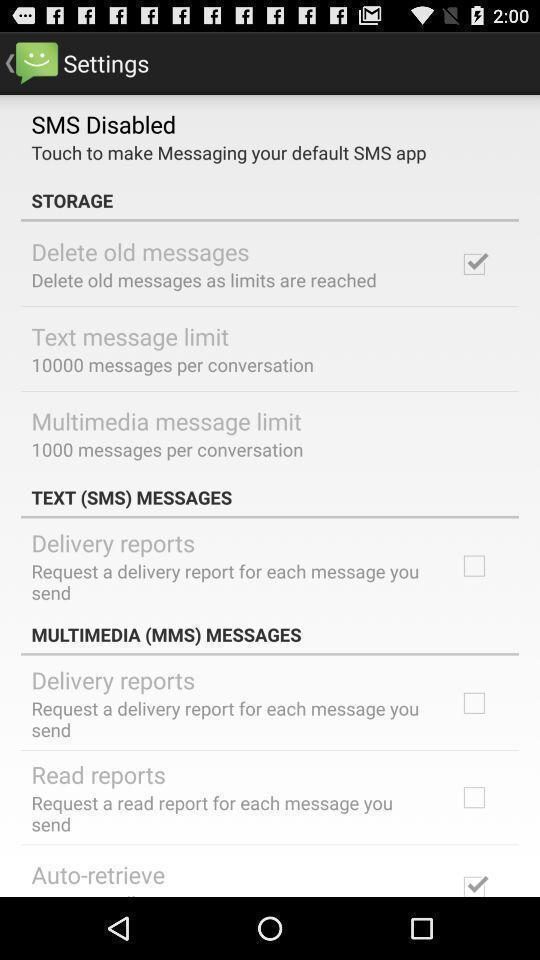Describe the visual elements of this screenshot. Settings page. 